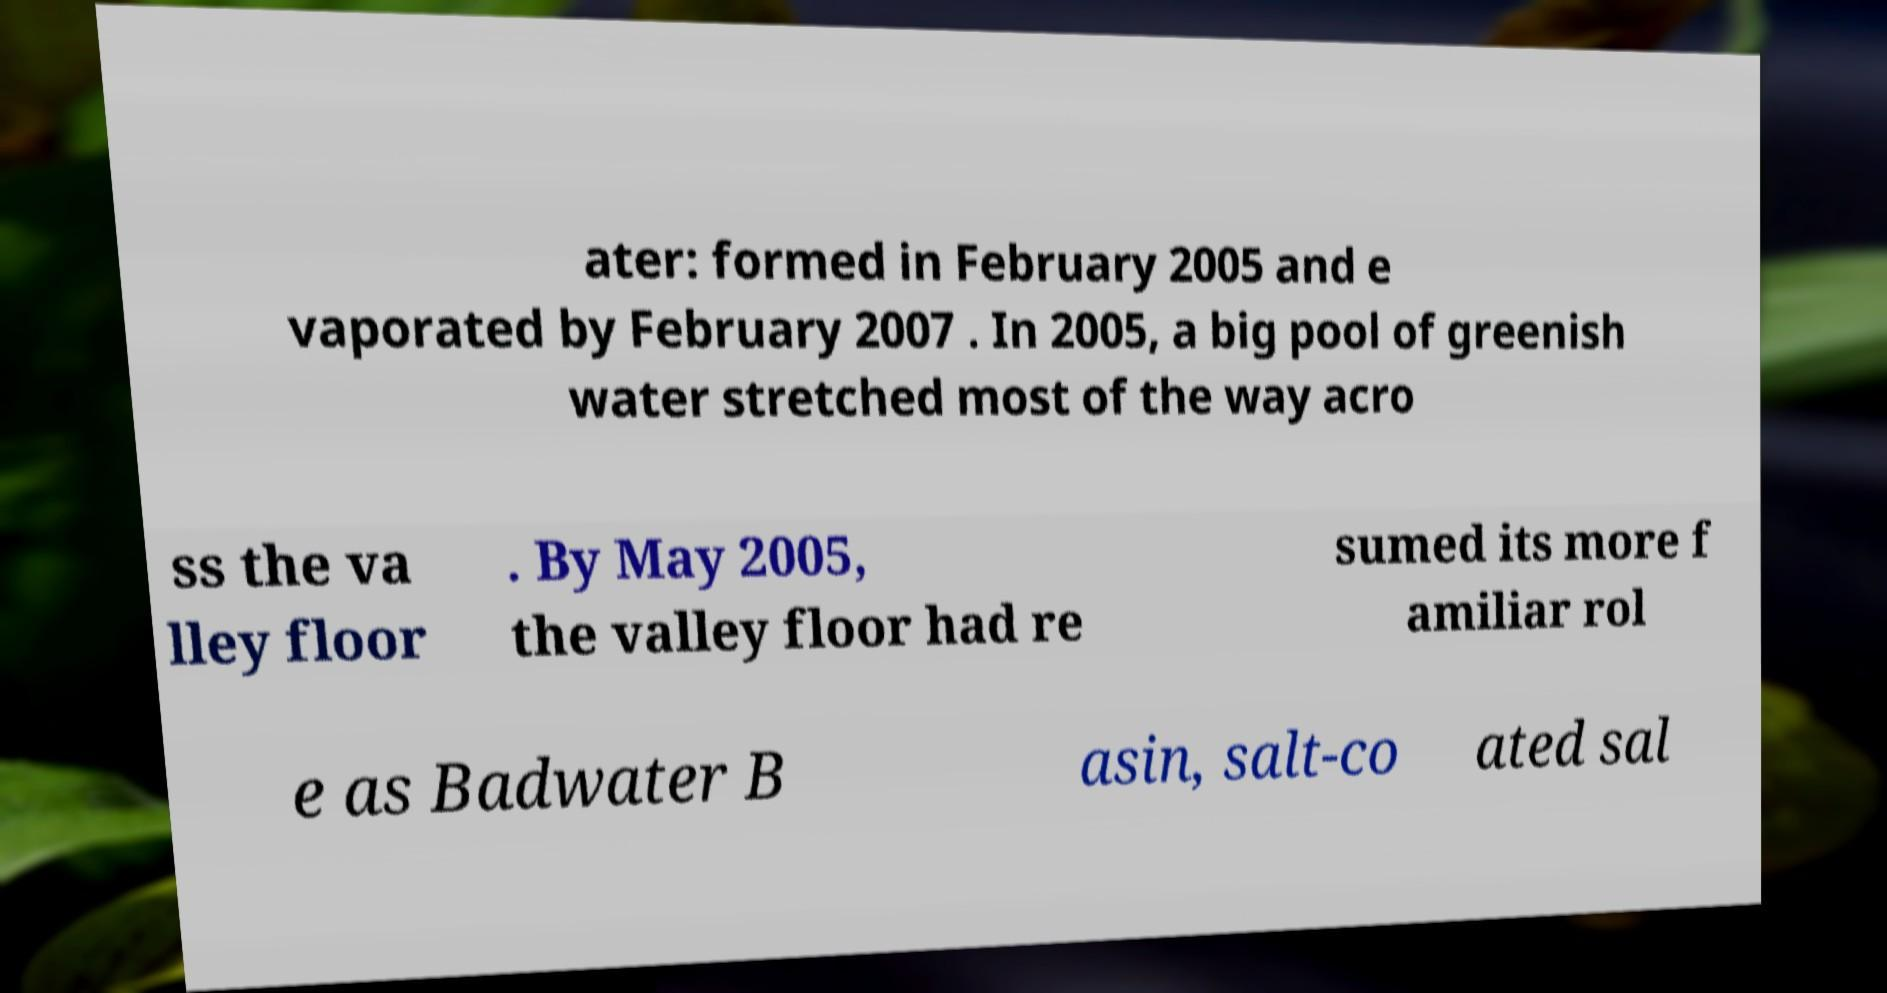There's text embedded in this image that I need extracted. Can you transcribe it verbatim? ater: formed in February 2005 and e vaporated by February 2007 . In 2005, a big pool of greenish water stretched most of the way acro ss the va lley floor . By May 2005, the valley floor had re sumed its more f amiliar rol e as Badwater B asin, salt-co ated sal 